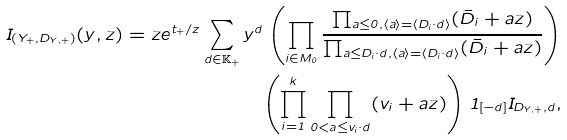Convert formula to latex. <formula><loc_0><loc_0><loc_500><loc_500>I _ { ( Y _ { + } , D _ { Y , + } ) } ( y , z ) = z e ^ { t _ { + } / z } \sum _ { d \in \mathbb { K } _ { + } } y ^ { d } \left ( \prod _ { i \in M _ { 0 } } \frac { \prod _ { a \leq 0 , \langle a \rangle = \langle D _ { i } \cdot d \rangle } ( \bar { D } _ { i } + a z ) } { \prod _ { a \leq D _ { i } \cdot d , \langle a \rangle = \langle D _ { i } \cdot d \rangle } ( \bar { D } _ { i } + a z ) } \right ) \\ \left ( \prod _ { i = 1 } ^ { k } \prod _ { 0 < a \leq v _ { i } \cdot d } ( v _ { i } + a z ) \right ) 1 _ { [ - d ] } I _ { D _ { Y , + } , d } ,</formula> 